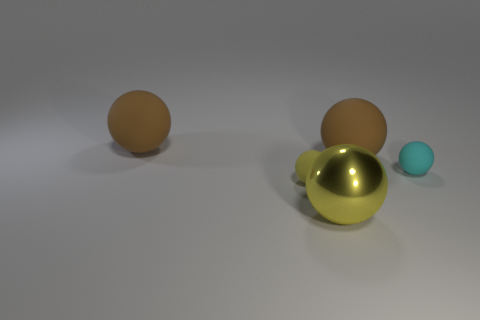How might the varying sizes of the objects influence our perception of the scene? The varying sizes of the objects might suggest depth and perspective. The largest sphere appears closer due to its size and reflective surface, which draws the eye. The smaller spheres, especially the teal one, could seem farther away. This arrangement invites an exploration of spatial relations and could be emblematic of the way objects of different sizes and textures interact with light and space. 